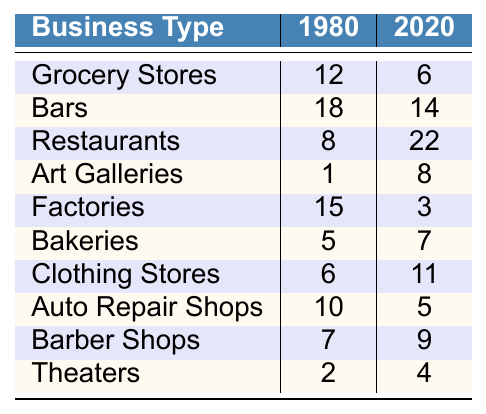What was the number of groceries stores in Detroit Shoreway in 1980? The table indicates that there were 12 grocery stores listed under the year 1980.
Answer: 12 How many auto repair shops were present in 2020? The table shows that there were 5 auto repair shops in the year 2020.
Answer: 5 Which business type had the highest number of establishments in 1980? By comparing all values under 1980, factories had the highest number with 15 establishments.
Answer: Factories Did the number of restaurants increase from 1980 to 2020? In 1980 there were 8 restaurants and in 2020 there were 22 restaurants, indicating an increase.
Answer: Yes What is the difference in the number of bars between 1980 and 2020? There were 18 bars in 1980 and 14 in 2020. The difference is 18 - 14 = 4.
Answer: 4 How many art galleries were there in total in 1980 and 2020? Summing the values from the table: in 1980 there was 1 and in 2020 there were 8, so total is 1 + 8 = 9.
Answer: 9 Is the number of bakeries higher in 2020 compared to 1980? The table shows that there were 5 bakeries in 1980 and 7 in 2020. Since 7 > 5, the number of bakeries is higher in 2020.
Answer: Yes What percentage of factories from 1980 are still in operation in 2020? The number of factories went from 15 in 1980 to 3 in 2020. To find the percentage: (3/15) * 100 = 20%.
Answer: 20% Which business type showed the greatest increase in number from 1980 to 2020? The number of restaurants increased from 8 to 22, a difference of 14, which is the largest increase compared to other types.
Answer: Restaurants What was the total number of all business types in 1980? Adding all values for 1980: 12 + 18 + 8 + 1 + 15 + 5 + 6 + 10 + 7 + 2 = 80.
Answer: 80 